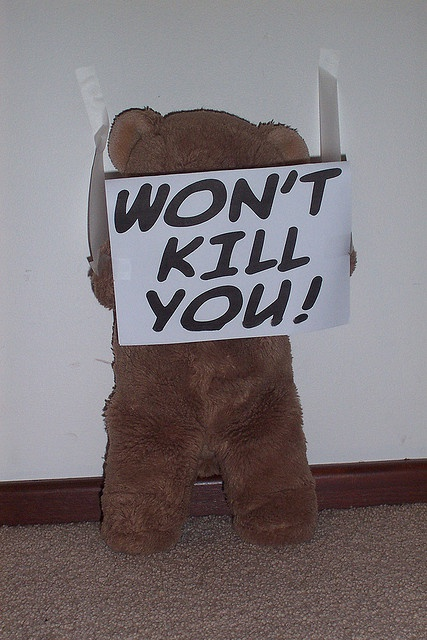Describe the objects in this image and their specific colors. I can see a teddy bear in gray, maroon, black, and brown tones in this image. 